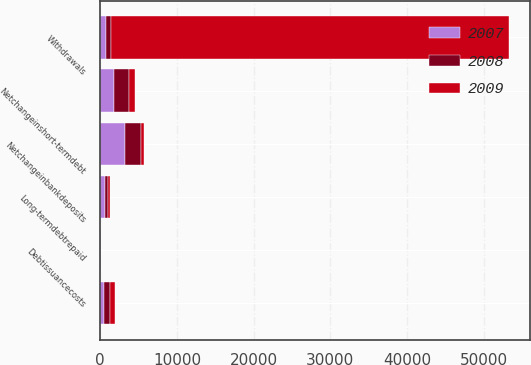Convert chart to OTSL. <chart><loc_0><loc_0><loc_500><loc_500><stacked_bar_chart><ecel><fcel>Withdrawals<fcel>Unnamed: 2<fcel>Netchangeinbankdeposits<fcel>Netchangeinshort-termdebt<fcel>Long-termdebtrepaid<fcel>Debtissuancecosts<nl><fcel>2007<fcel>722<fcel>500<fcel>3164<fcel>1747<fcel>555<fcel>30<nl><fcel>2008<fcel>722<fcel>750<fcel>2185<fcel>1992<fcel>422<fcel>34<nl><fcel>2009<fcel>51903<fcel>694<fcel>305<fcel>782<fcel>286<fcel>14<nl></chart> 